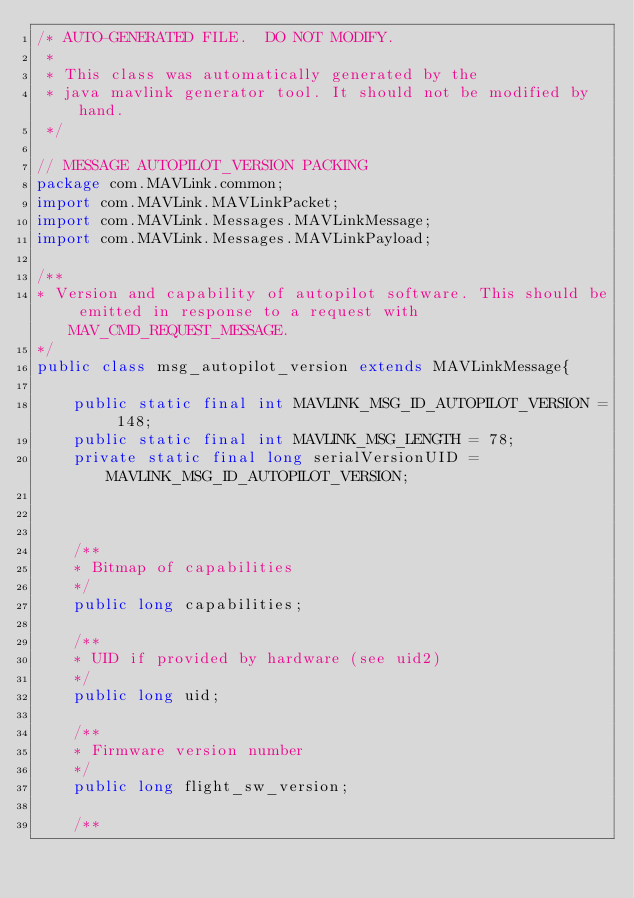<code> <loc_0><loc_0><loc_500><loc_500><_Java_>/* AUTO-GENERATED FILE.  DO NOT MODIFY.
 *
 * This class was automatically generated by the
 * java mavlink generator tool. It should not be modified by hand.
 */

// MESSAGE AUTOPILOT_VERSION PACKING
package com.MAVLink.common;
import com.MAVLink.MAVLinkPacket;
import com.MAVLink.Messages.MAVLinkMessage;
import com.MAVLink.Messages.MAVLinkPayload;
        
/**
* Version and capability of autopilot software. This should be emitted in response to a request with MAV_CMD_REQUEST_MESSAGE.
*/
public class msg_autopilot_version extends MAVLinkMessage{

    public static final int MAVLINK_MSG_ID_AUTOPILOT_VERSION = 148;
    public static final int MAVLINK_MSG_LENGTH = 78;
    private static final long serialVersionUID = MAVLINK_MSG_ID_AUTOPILOT_VERSION;


      
    /**
    * Bitmap of capabilities
    */
    public long capabilities;
      
    /**
    * UID if provided by hardware (see uid2)
    */
    public long uid;
      
    /**
    * Firmware version number
    */
    public long flight_sw_version;
      
    /**</code> 